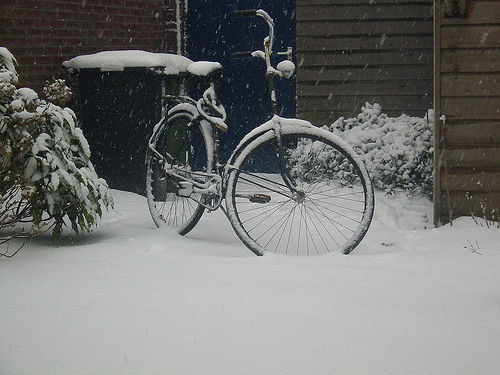What could be the reason the bicycle is left in the snow? The bicycle may have been left out before a sudden snowfall, indicating that the owner did not anticipate such weather, or perhaps it is a forgotten item that serves as a reminder of the wintry season's impact on daily life. 